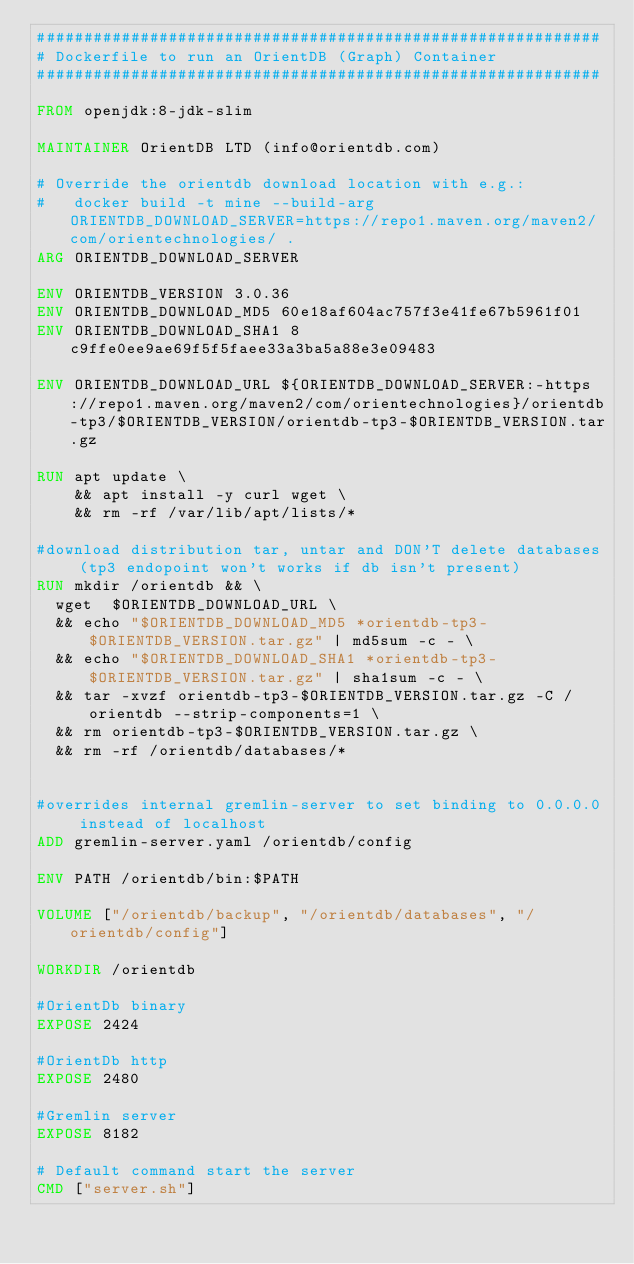Convert code to text. <code><loc_0><loc_0><loc_500><loc_500><_Dockerfile_>############################################################
# Dockerfile to run an OrientDB (Graph) Container
############################################################

FROM openjdk:8-jdk-slim

MAINTAINER OrientDB LTD (info@orientdb.com)

# Override the orientdb download location with e.g.:
#   docker build -t mine --build-arg ORIENTDB_DOWNLOAD_SERVER=https://repo1.maven.org/maven2/com/orientechnologies/ .
ARG ORIENTDB_DOWNLOAD_SERVER

ENV ORIENTDB_VERSION 3.0.36
ENV ORIENTDB_DOWNLOAD_MD5 60e18af604ac757f3e41fe67b5961f01
ENV ORIENTDB_DOWNLOAD_SHA1 8c9ffe0ee9ae69f5f5faee33a3ba5a88e3e09483

ENV ORIENTDB_DOWNLOAD_URL ${ORIENTDB_DOWNLOAD_SERVER:-https://repo1.maven.org/maven2/com/orientechnologies}/orientdb-tp3/$ORIENTDB_VERSION/orientdb-tp3-$ORIENTDB_VERSION.tar.gz

RUN apt update \
    && apt install -y curl wget \
    && rm -rf /var/lib/apt/lists/* 

#download distribution tar, untar and DON'T delete databases (tp3 endopoint won't works if db isn't present)
RUN mkdir /orientdb && \
  wget  $ORIENTDB_DOWNLOAD_URL \
  && echo "$ORIENTDB_DOWNLOAD_MD5 *orientdb-tp3-$ORIENTDB_VERSION.tar.gz" | md5sum -c - \
  && echo "$ORIENTDB_DOWNLOAD_SHA1 *orientdb-tp3-$ORIENTDB_VERSION.tar.gz" | sha1sum -c - \
  && tar -xvzf orientdb-tp3-$ORIENTDB_VERSION.tar.gz -C /orientdb --strip-components=1 \
  && rm orientdb-tp3-$ORIENTDB_VERSION.tar.gz \
  && rm -rf /orientdb/databases/*


#overrides internal gremlin-server to set binding to 0.0.0.0 instead of localhost
ADD gremlin-server.yaml /orientdb/config

ENV PATH /orientdb/bin:$PATH

VOLUME ["/orientdb/backup", "/orientdb/databases", "/orientdb/config"]

WORKDIR /orientdb

#OrientDb binary
EXPOSE 2424

#OrientDb http
EXPOSE 2480

#Gremlin server
EXPOSE 8182

# Default command start the server
CMD ["server.sh"]

</code> 